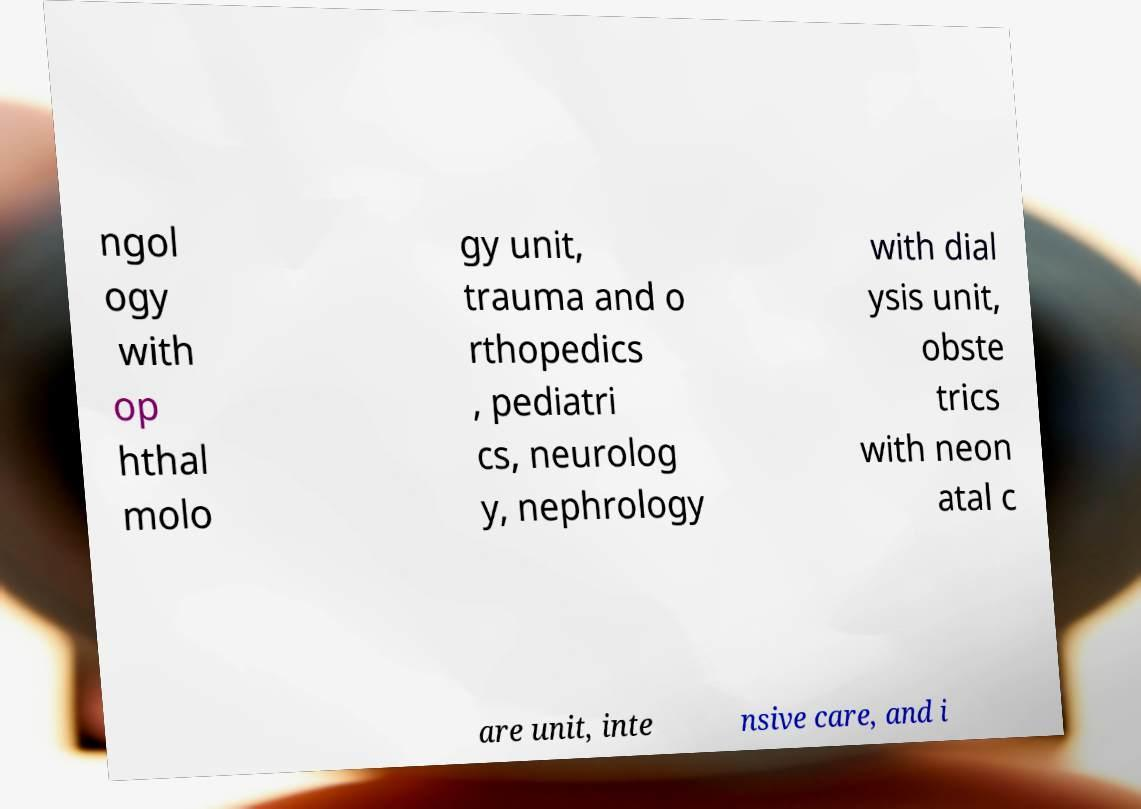I need the written content from this picture converted into text. Can you do that? ngol ogy with op hthal molo gy unit, trauma and o rthopedics , pediatri cs, neurolog y, nephrology with dial ysis unit, obste trics with neon atal c are unit, inte nsive care, and i 